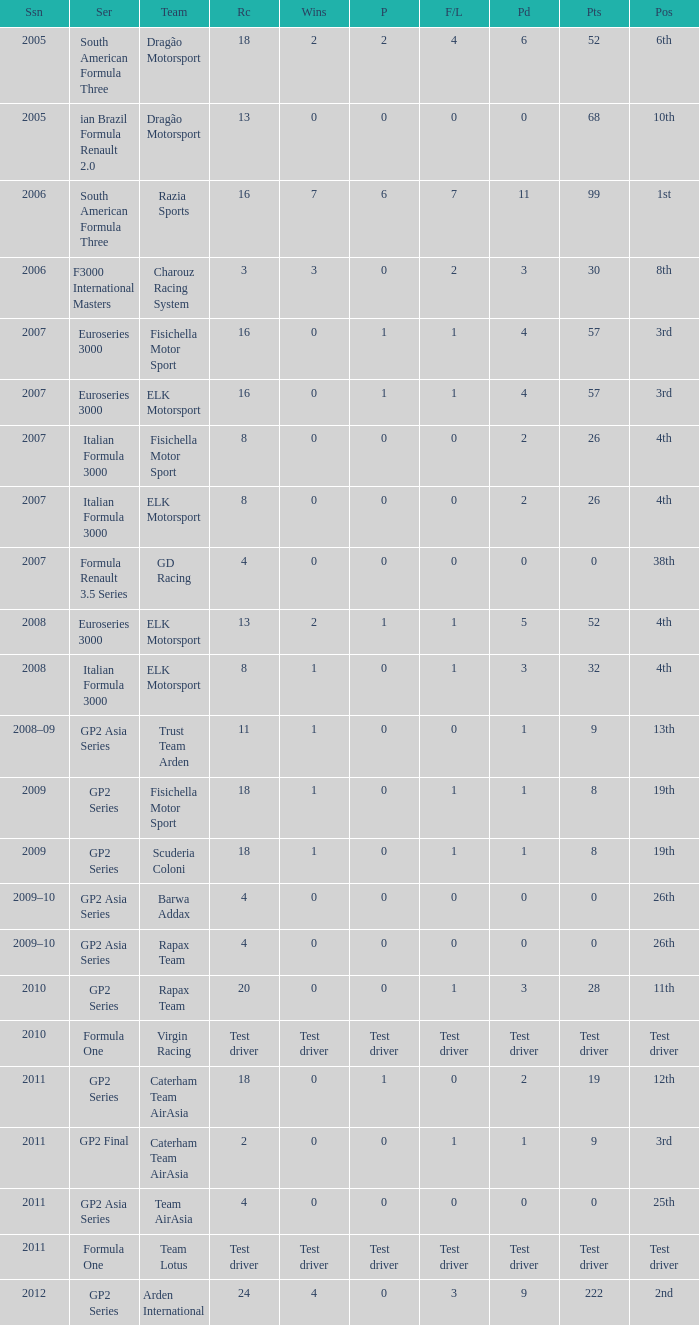What was his position in 2009 with 1 win? 19th, 19th. 